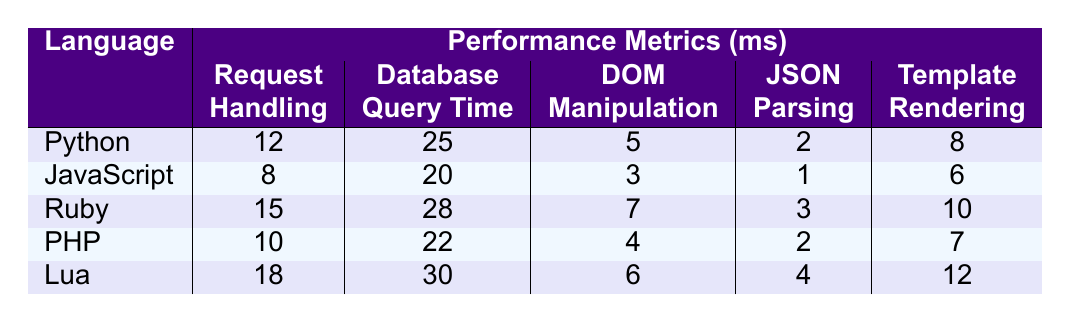What is the request handling time for JavaScript? The table indicates that the request handling time for JavaScript is 8 ms.
Answer: 8 ms Which language has the shortest database query time? By examining the table, the shortest database query time is recorded for JavaScript at 20 ms.
Answer: JavaScript What is the average DOM manipulation time across all languages? Summing the DOM manipulation times gives (5 + 3 + 7 + 4 + 6) = 25 ms. With 5 languages, the average is 25/5 = 5 ms.
Answer: 5 ms True or False: Python has a longer JSON parsing time than PHP. Looking at the table, Python's JSON parsing time is 2 ms, while PHP's is also 2 ms, meaning they are equal, so the statement is false.
Answer: False Which programming language has the longest template rendering time? By checking the table, Lua has the longest template rendering time at 12 ms.
Answer: Lua What is the difference in request handling time between Ruby and PHP? Ruby's request handling time is 15 ms and PHP's is 10 ms. The difference is 15 - 10 = 5 ms.
Answer: 5 ms Which language performs best in DOM manipulation when comparing JavaScript with Python? JavaScript has a DOM manipulation time of 3 ms compared to Python's 5 ms, indicating that JavaScript performs better.
Answer: JavaScript What is the total time taken for all performance metrics combined in Ruby? Adding Ruby's times gives (15 + 28 + 7 + 3 + 10) = 63 ms as the total for all metrics.
Answer: 63 ms Is the database query time for Lua greater than that for Python? Lua's database query time is 30 ms while Python's is 25 ms, confirming that Lua indeed has a greater time.
Answer: Yes Which language has the lowest average time across all performance metrics? Calculating the average for each language: Python (12+25+5+2+8)/5 = 10.4, JavaScript (8+20+3+1+6)/5 = 7.6, Ruby (15+28+7+3+10)/5 = 12.6, PHP (10+22+4+2+7)/5 = 9, Lua (18+30+6+4+12)/5 = 14.
Answer: JavaScript 